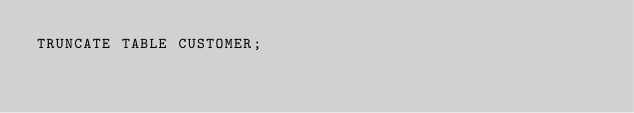Convert code to text. <code><loc_0><loc_0><loc_500><loc_500><_SQL_>TRUNCATE TABLE CUSTOMER;</code> 